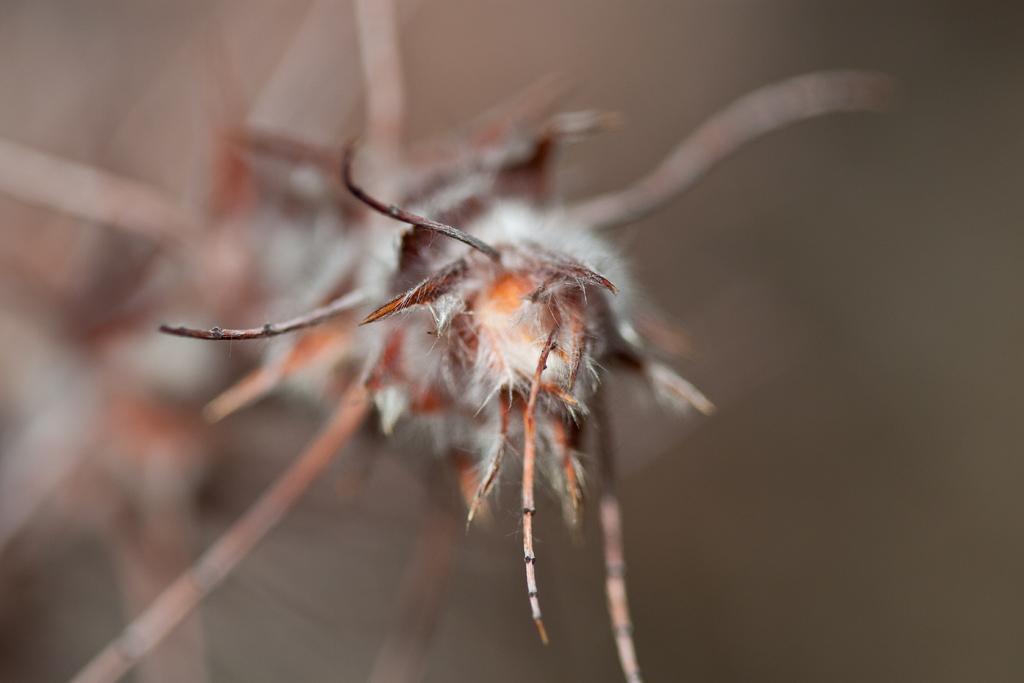How would you summarize this image in a sentence or two? It is the macro photography of an insect. 